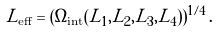Convert formula to latex. <formula><loc_0><loc_0><loc_500><loc_500>L _ { \text {eff} } = ( \Omega _ { \text {int} } ( L _ { 1 } , L _ { 2 } , L _ { 3 } , L _ { 4 } ) ) ^ { 1 / 4 } \, .</formula> 